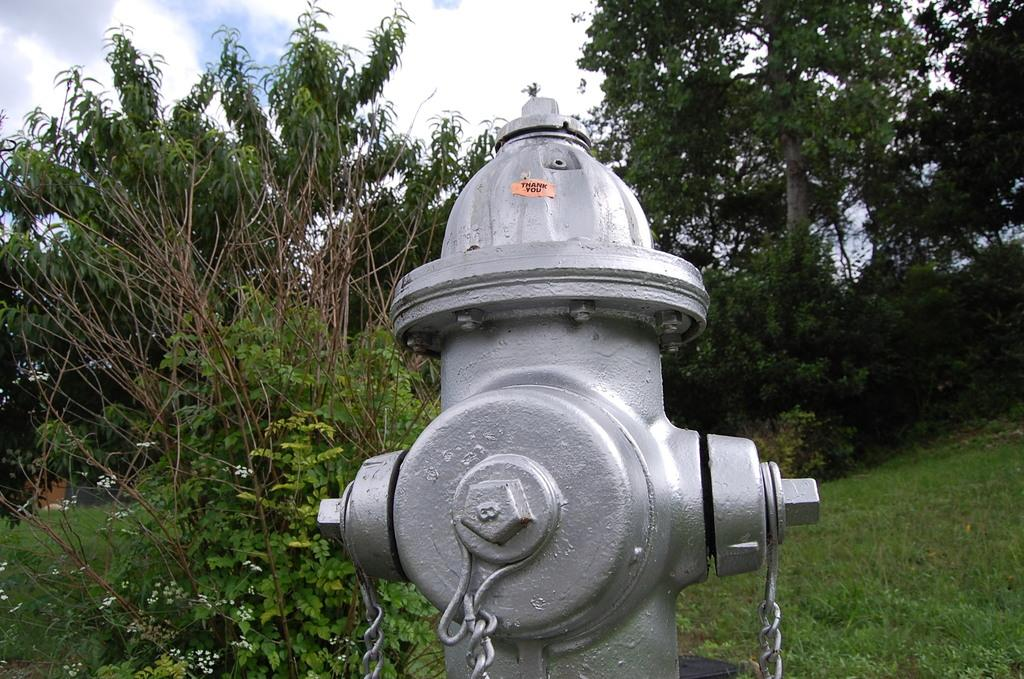What object is present in the image that is typically used for firefighting? There is a fire hydrant in the image. What type of vegetation can be seen in the image? There are trees in the image. What is the ground covered with in the image? There is grass visible in the image. What can be seen in the sky in the image? There are clouds in the sky in the image. What type of plate is being used by the dog in the image? There is no dog or plate present in the image. What type of pen is visible in the image? There is no pen present in the image. 